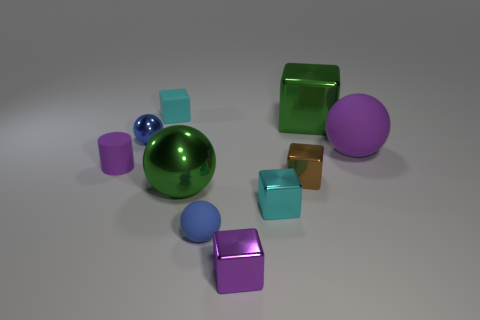Subtract all big matte balls. How many balls are left? 3 Subtract all purple spheres. How many spheres are left? 3 Subtract all green blocks. Subtract all green cylinders. How many blocks are left? 4 Subtract all balls. How many objects are left? 6 Subtract 0 brown balls. How many objects are left? 10 Subtract all rubber blocks. Subtract all tiny brown metallic objects. How many objects are left? 8 Add 3 brown shiny cubes. How many brown shiny cubes are left? 4 Add 6 large metallic cubes. How many large metallic cubes exist? 7 